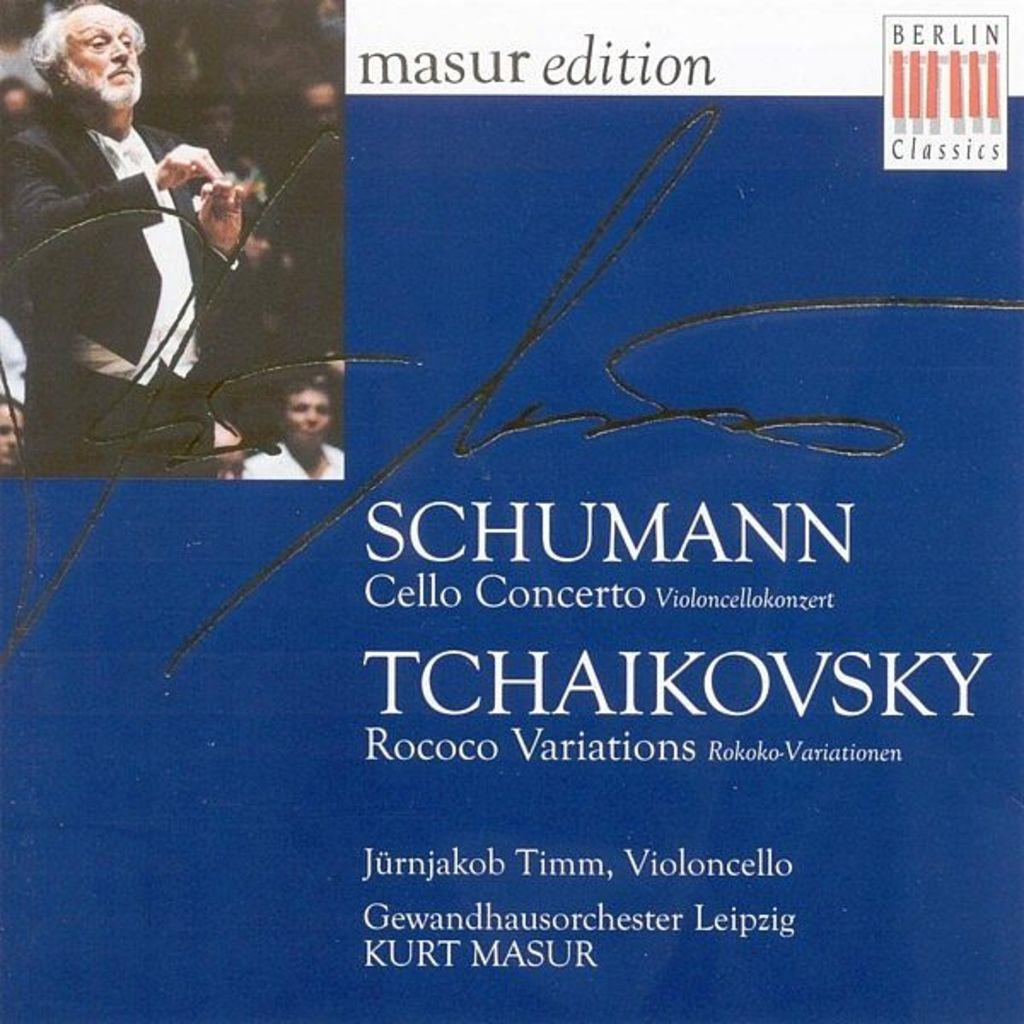What is the main subject of the image? The main subject of the image is a cover page of a book. What can be seen on the cover page? The cover page has a signature. Is there any other element in the image besides the cover page? Yes, there is a picture of a man standing in the image. How many dolls are displayed on the list in the image? There is no list or dolls present in the image. 